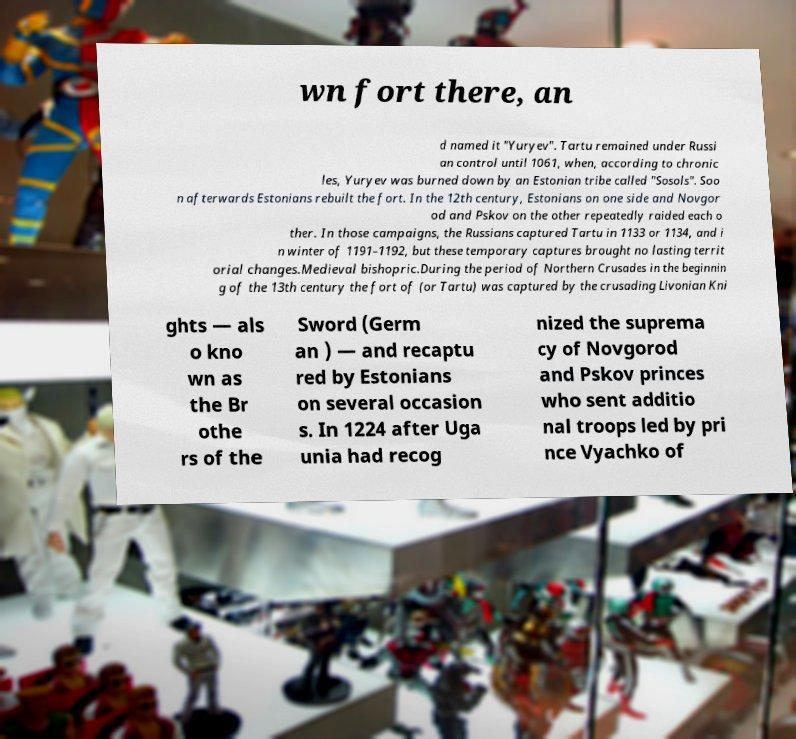Please read and relay the text visible in this image. What does it say? wn fort there, an d named it "Yuryev". Tartu remained under Russi an control until 1061, when, according to chronic les, Yuryev was burned down by an Estonian tribe called "Sosols". Soo n afterwards Estonians rebuilt the fort. In the 12th century, Estonians on one side and Novgor od and Pskov on the other repeatedly raided each o ther. In those campaigns, the Russians captured Tartu in 1133 or 1134, and i n winter of 1191–1192, but these temporary captures brought no lasting territ orial changes.Medieval bishopric.During the period of Northern Crusades in the beginnin g of the 13th century the fort of (or Tartu) was captured by the crusading Livonian Kni ghts — als o kno wn as the Br othe rs of the Sword (Germ an ) — and recaptu red by Estonians on several occasion s. In 1224 after Uga unia had recog nized the suprema cy of Novgorod and Pskov princes who sent additio nal troops led by pri nce Vyachko of 